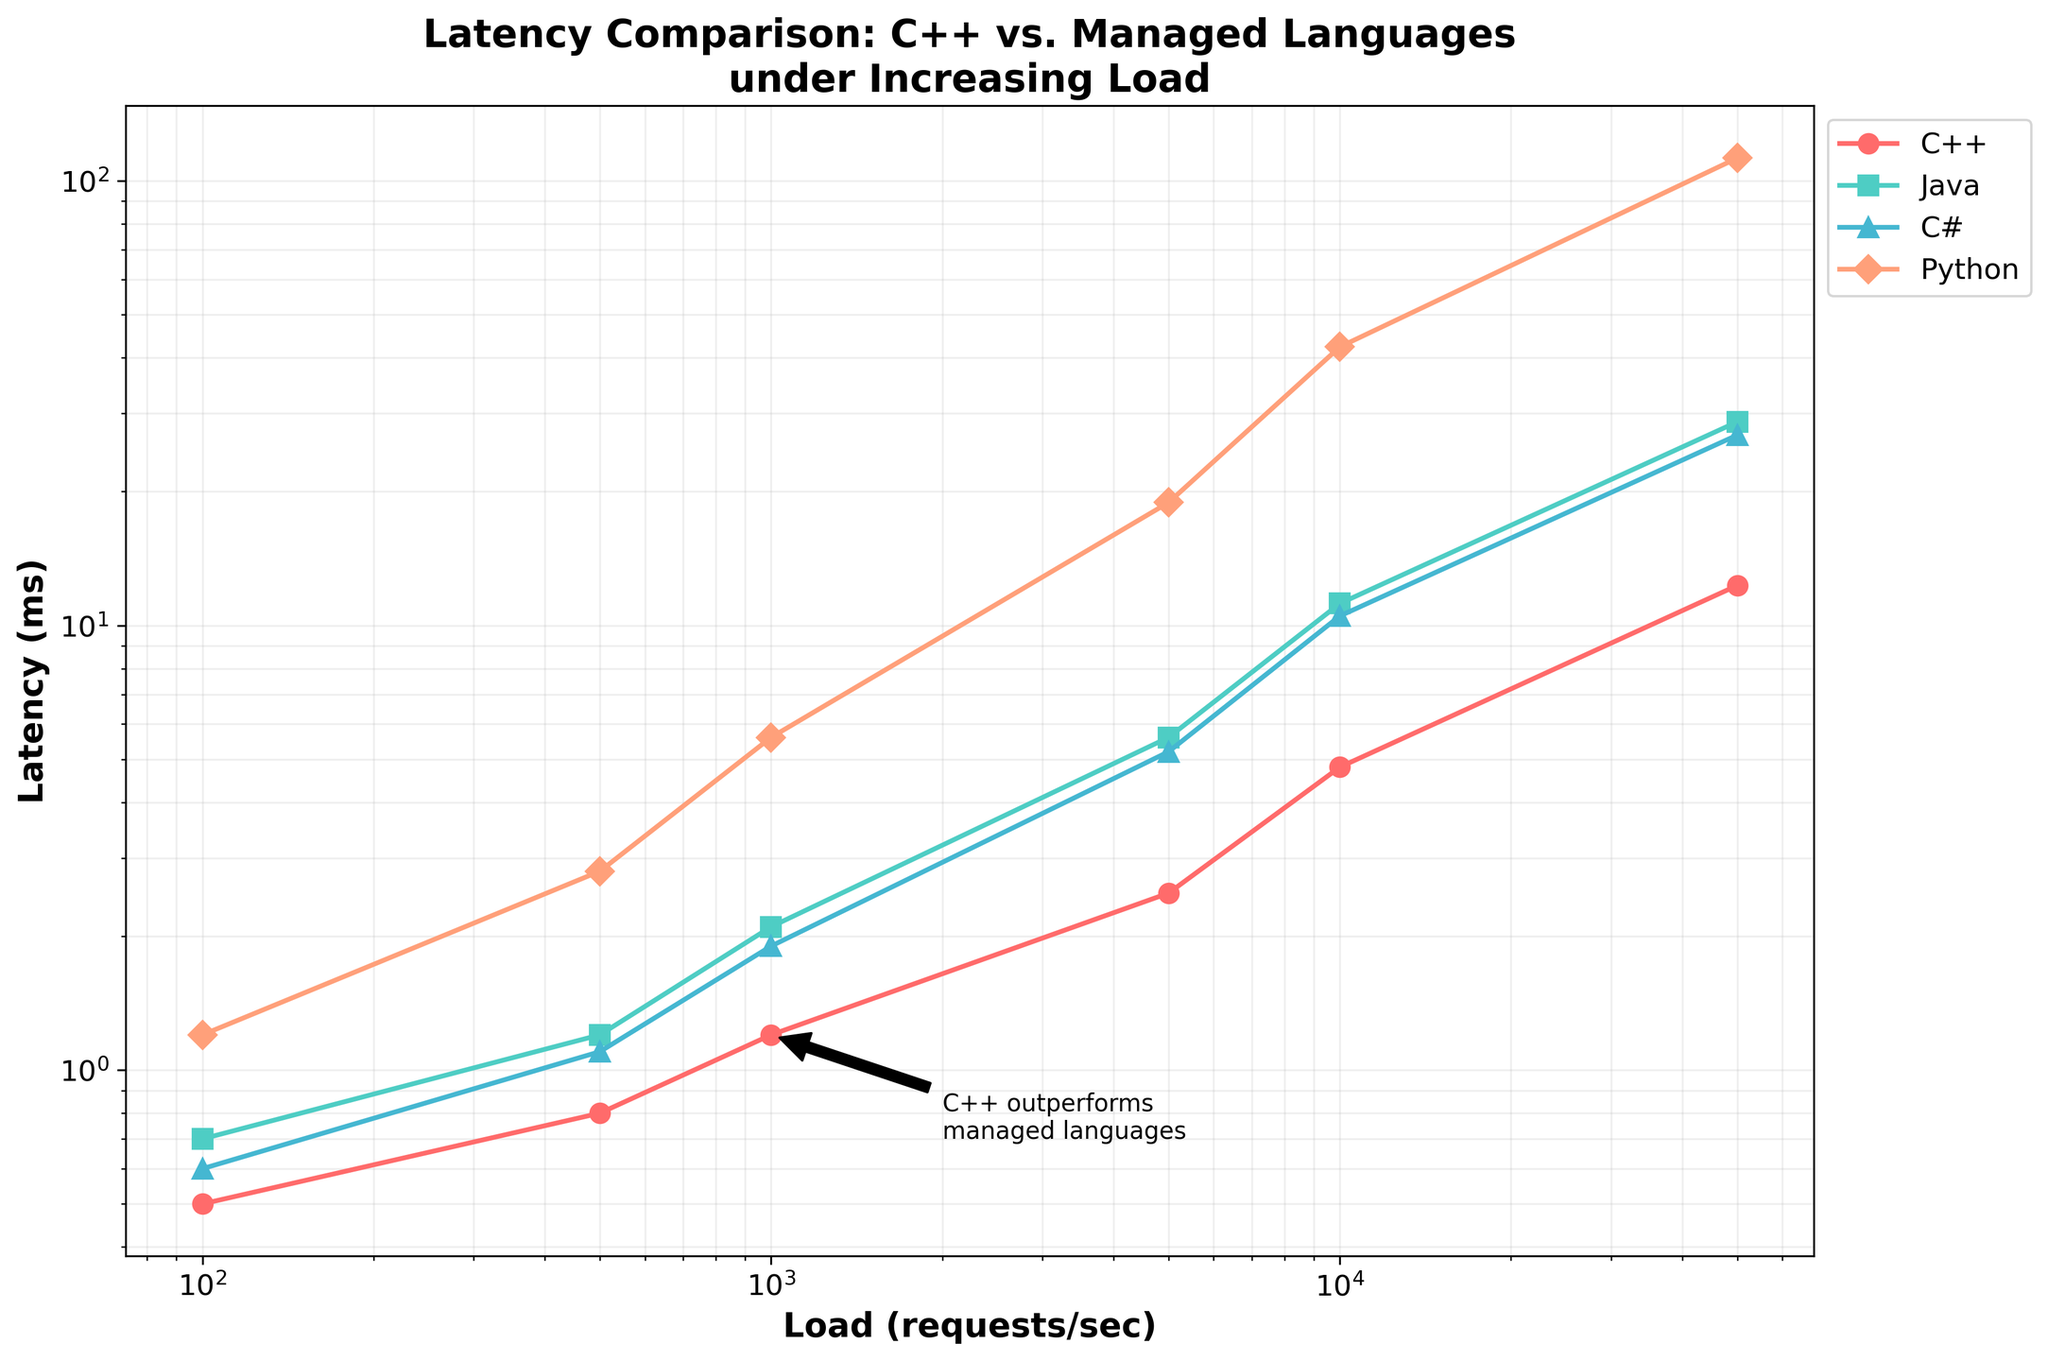What general trend can be observed in the latency of C++ with increasing load? As the load increases, the latency of C++ gradually increases. At loads of 100 and 500 requests/sec, the latency remains below 1 ms. However, at 10000 and 50000 requests/sec, the latency increases significantly to 4.8 ms and 12.3 ms, respectively.
Answer: The latency increases with load Which language has the highest latency at 50000 requests/sec? Observing the plot at the 50000 requests/sec point shows that Python has the highest latency with a value soaring to 112.5 ms. This is visually evident as Python's line reaches a higher point on the y-axis compared to the other languages at this load.
Answer: Python Between Java and C#, which language has higher latency at 10000 requests/sec, and by how much? At 10000 requests/sec, Java's latency is 11.2 ms, while C# records 10.5 ms. To find the difference, we subtract 10.5 from 11.2, giving us 0.7 ms. Hence, Java has a 0.7 ms higher latency than C# at this load.
Answer: Java by 0.7 ms What color represents C++ in the plot? By looking at the color-coded lines on the plot, the line representing C++ is denoted by the color red.
Answer: Red How much does C++'s latency increase from 1000 requests/sec to 50000 requests/sec? C++'s latency at 1000 requests/sec is 1.2 ms and at 50000 requests/sec is 12.3 ms. To find the increase, we subtract 1.2 from 12.3, yielding 11.1 ms.
Answer: 11.1 ms Is there a point where Java's latency is less than C#'s latency? A close examination of the plot shows that at each load level, Java's latency is at least equal to or greater than C#'s latency. Therefore, at no point does Java's latency drop below C#'s latency.
Answer: No Compare the latency difference between C++ and Python at 5000 requests/sec. C++ has a latency of 2.5 ms at 5000 requests/sec, whereas Python's latency is significantly higher at 18.9 ms. Subtracting 2.5 from 18.9 gives us a difference of 16.4 ms.
Answer: 16.4 ms At what load level does the latency of C++ and Java start to diverge significantly? Examining the plot, C++ and Java show a marked divergence starting from around 1000 requests/sec onward. At this point, C++ has a latency of 1.2 ms, while Java's latency is 2.1 ms.
Answer: 1000 requests/sec What is the visual annotation pointing out about C++'s performance in the plot? The annotation on the plot states "C++ outperforms managed languages," indicating that C++ maintains lower latency under increasing load conditions compared to the managed languages like Java, C#, and Python.
Answer: C++ outperforms managed languages 